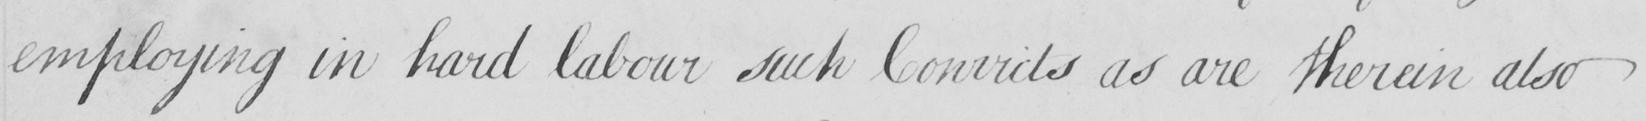Can you read and transcribe this handwriting? employing in hard labour such Convicts as are therein also 